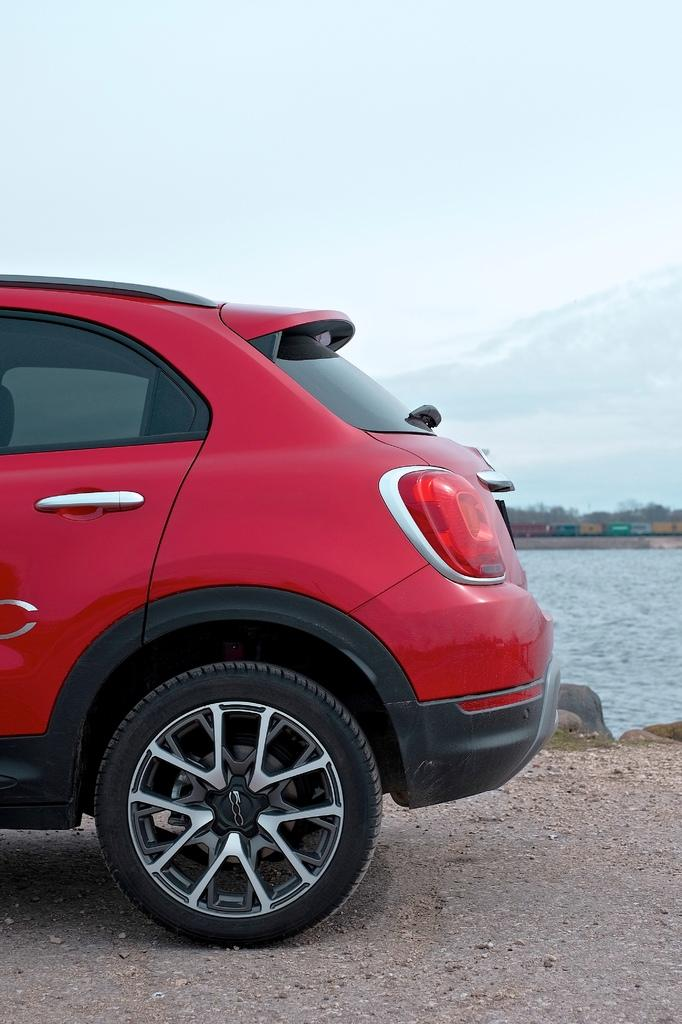What is the color of the car in the image? The car in the image is red. What can be seen in the background of the image? The sky, clouds, trees, a train, water, and stones are visible in the background. Can you describe the train in the background? The train is in the background, but no specific details about the train are provided in the facts. How many cats are sitting on the car in the image? There are no cats present in the image. What direction is the car looking in the image? Cars do not have the ability to look in a specific direction, so this question cannot be answered. 